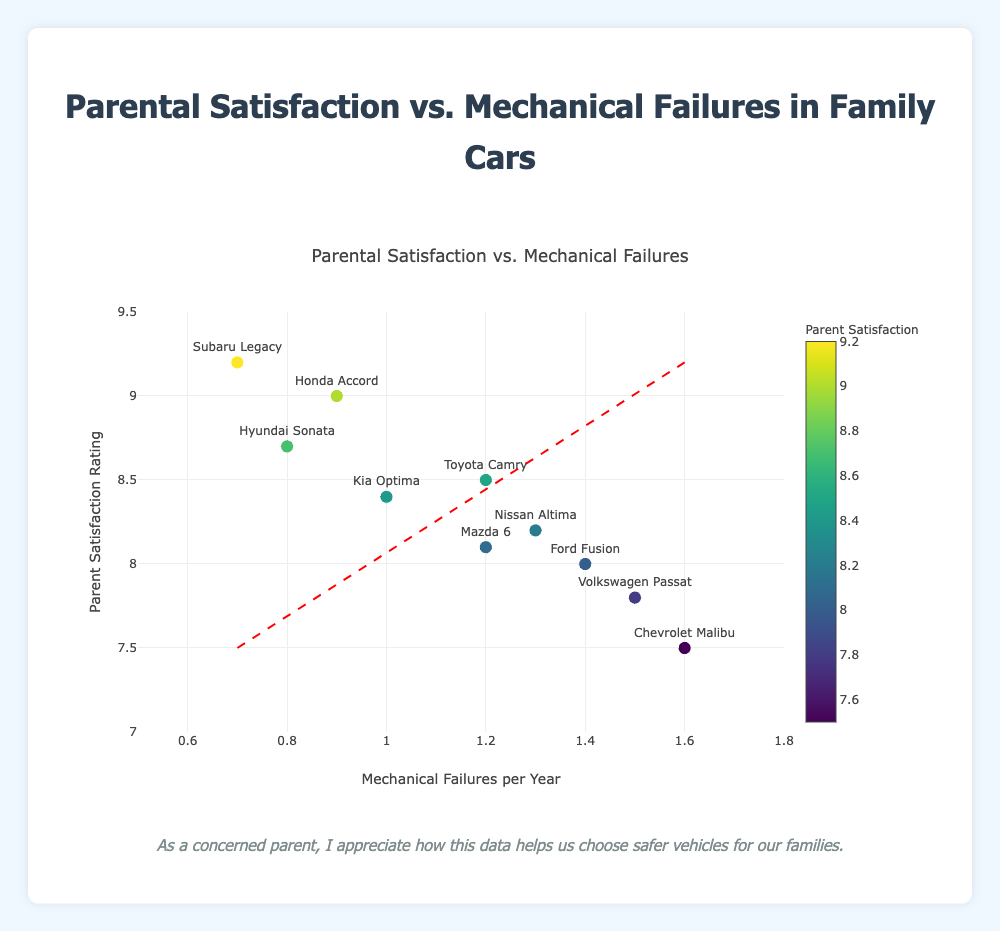What's the title of the figure? The title is located at the top of the figure.
Answer: Parental Satisfaction vs. Mechanical Failures How many different vehicle models are represented? Each marker represents a vehicle model, and we can count them. There are 10 markers.
Answer: 10 What is the mechanical failures per year for the Nissan Altima? Look for the Nissan Altima on the plot; its label and hover information provide this data.
Answer: 1.3 Which vehicle model has the highest parental satisfaction rating? Identify the highest point on the y-axis indicating the highest satisfaction rating. The label shows it is the Subaru Legacy.
Answer: Subaru Legacy Which vehicle has the lowest number of mechanical failures per year? Identify the point furthest left on the x-axis, this vehicle has the least mechanical failures.
Answer: Subaru Legacy What's the relationship between parental satisfaction and mechanical failures shown by the trend line? The trend line indicates the overall pattern or correlation between the data points. Since the trend line has a negative slope, it shows an inverse relationship: as mechanical failures increase, parental satisfaction decreases.
Answer: Inverse relationship What can you say about the satisfaction rating of the Chevrolet Malibu compared to the Hyundai Sonata? Locate both vehicles on the plot and compare their y-values. The Chevrolet Malibu has a satisfaction rating of 7.5, while the Hyundai Sonata has a rating of 8.7.
Answer: Hyundai Sonata has a higher satisfaction rating Which vehicle has a higher parental satisfaction rating than the Volkswagen Passat? Find the Volkswagen Passat on the plot and compare its y-value with other points. The Subaru Legacy, Honda Accord, Hyundai Sonata, Toyota Camry, Kia Optima, Nissan Altima, and Mazda 6 have higher ratings.
Answer: Subaru Legacy, Honda Accord, Hyundai Sonata, Toyota Camry, Kia Optima, Nissan Altima, Mazda 6 Between the Toyota Camry and the Mazda 6, which has a higher mechanical failure rate? Locate both vehicles on the plot and compare their x-values. The Toyota Camry has a mechanical failure rate of 1.2, and the Mazda 6 also has 1.2. Both are equal.
Answer: Equal What is the overall trend in parental satisfaction as mechanical failures increase? Look at the slope of the trend line; it shows a decreasing trend as mechanical failures increase.
Answer: Decreasing 